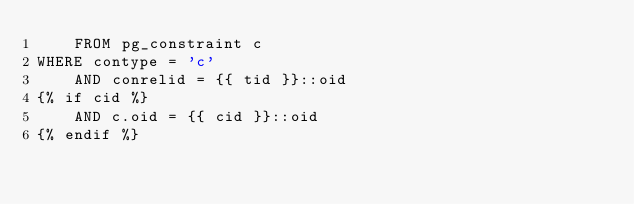Convert code to text. <code><loc_0><loc_0><loc_500><loc_500><_SQL_>    FROM pg_constraint c
WHERE contype = 'c'
    AND conrelid = {{ tid }}::oid
{% if cid %}
    AND c.oid = {{ cid }}::oid
{% endif %}
</code> 